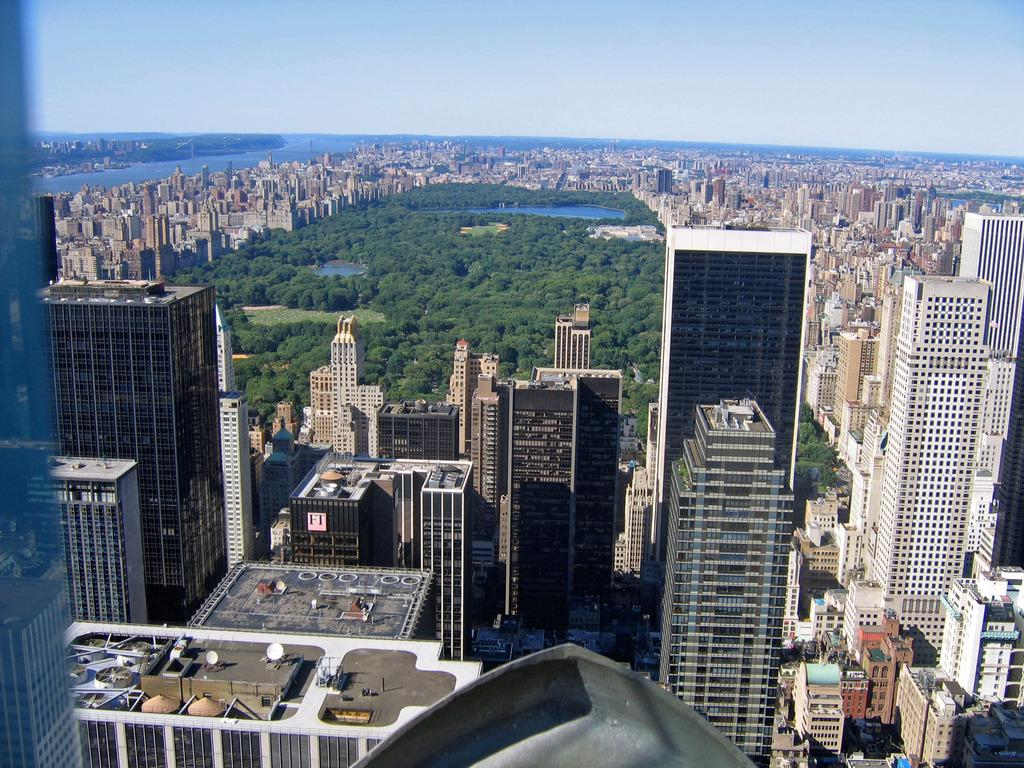What type of structures can be seen in the image? There are buildings in the image. What type of vegetation is present in the image? There are trees in the image. What type of natural features can be seen in the image? There are ponds in the image. What is visible in the background of the image? There is a water surface and the sky visible in the background. Where is the stocking hanging in the image? There is no stocking present in the image. What type of nest can be seen in the trees in the image? There are no nests visible in the trees in the image. 